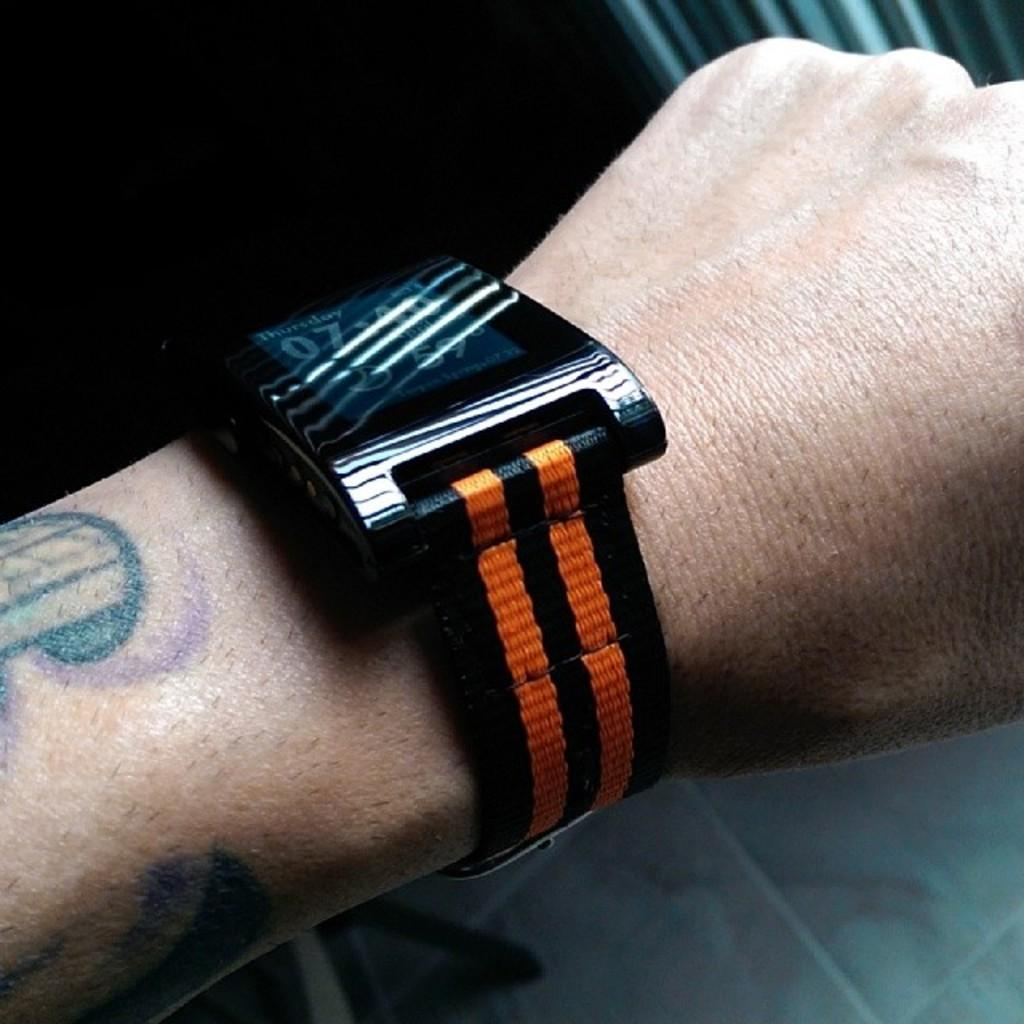Provide a one-sentence caption for the provided image. A watch with a back and orange band displays Thursday and 59 degrees. 